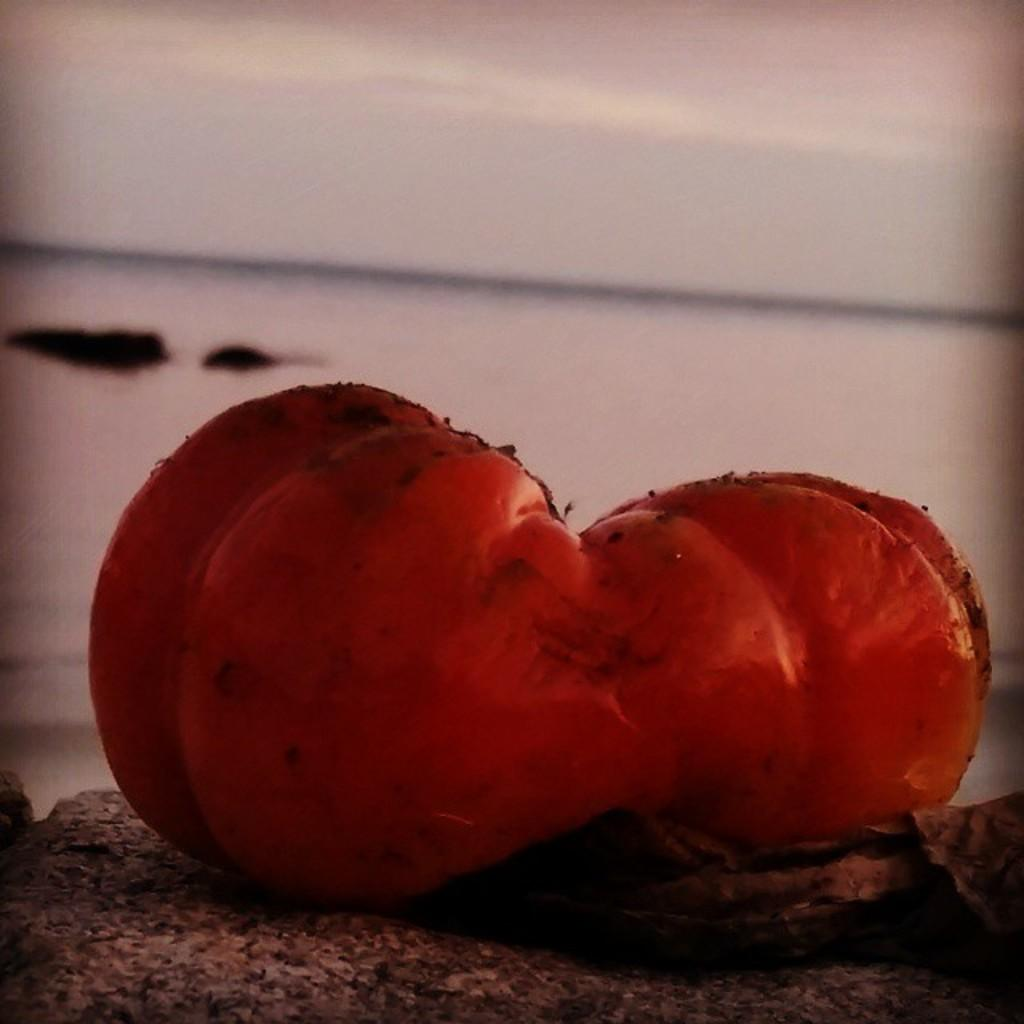What type of vegetable is in the foreground of the image? The specific type of vegetable is not mentioned, but there is a vegetable in the foreground of the image. What is located at the bottom of the image? There is a rock at the bottom of the image. What can be seen in the background of the image? There is a beach in the background of the image. What is visible at the top of the image? The sky is visible at the top of the image. Where is the faucet located in the image? There is no faucet present in the image. What type of breakfast is being served on the beach in the image? There is no breakfast or any food being served in the image. 